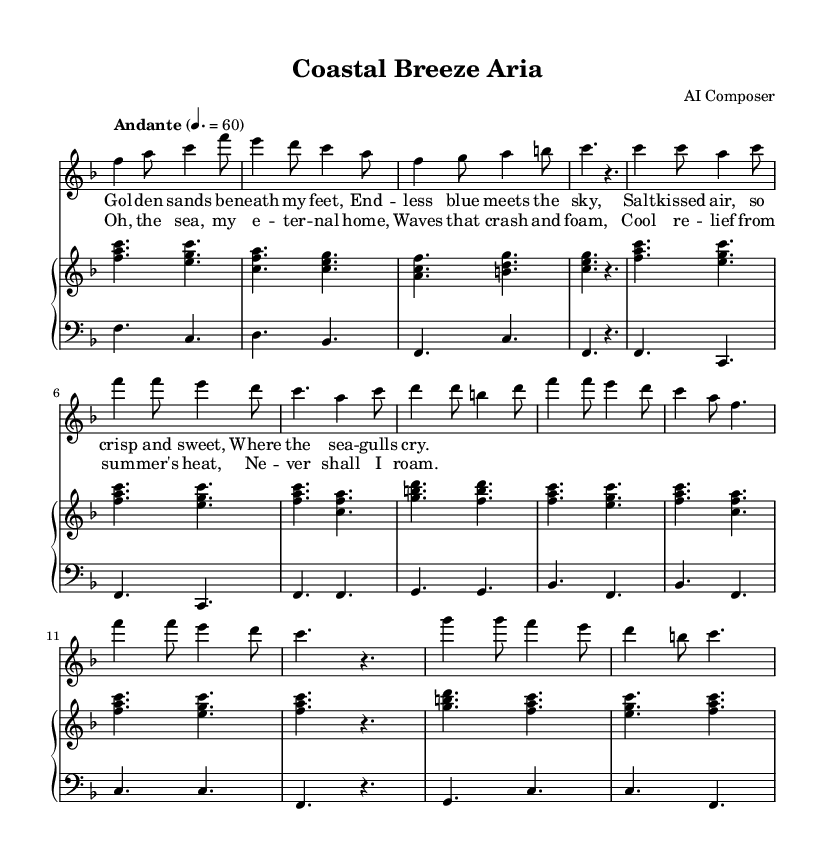What is the key signature of this music? The key signature is indicated at the beginning of the sheet music with one flat, which designates the key as F major.
Answer: F major What is the time signature of this music? The time signature is found at the beginning of the sheet music, showing that there are six beats per measure, with each beat divided into eighth notes. This indicates a time signature of 6/8.
Answer: 6/8 What is the tempo marking for this aria? The tempo marking is located near the beginning and states "Andante," which is a moderate pace. The metronome indication shows a speed of 60 beats per minute.
Answer: Andante How many verses are in this aria? The lyrics section includes a labeled "Verse 1" with a partial layout. Since there is no indication of additional verses in the provided music, we conclude there is one verse.
Answer: One What is the primary theme in the lyrics of this opera aria? The lyrics express an appreciation for the sea, coastal life, and the relief it brings from summer heat, indicating a deep connection with maritime themes.
Answer: Connection with the sea What vocal part is featured prominently in the score? The score indicates a "soprano" voice as the main vocal part, which is labeled at the start before the vocal line appears. This designation shows that the music is written for a higher female voice.
Answer: Soprano 